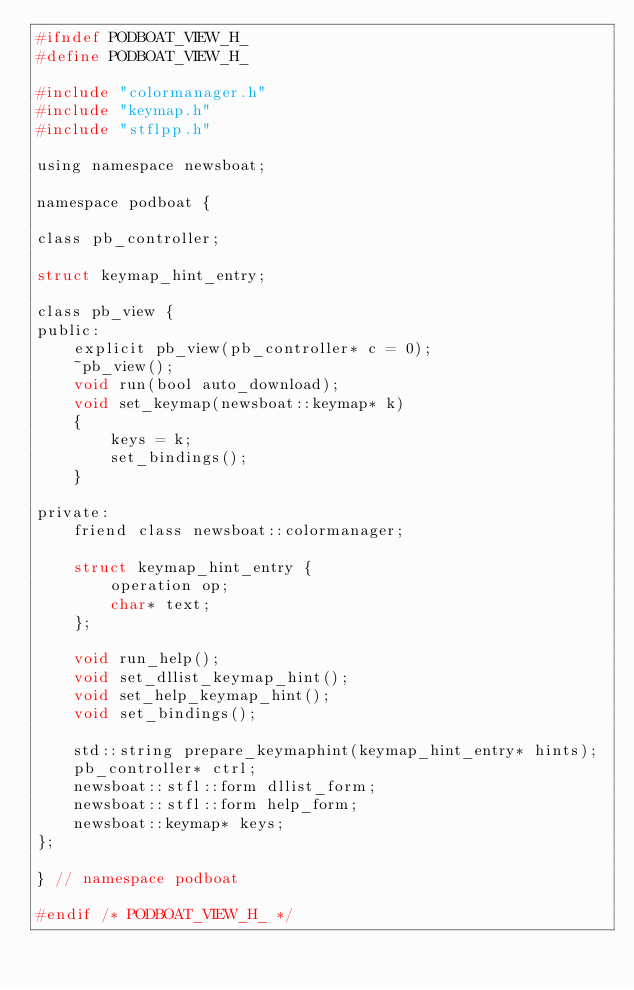Convert code to text. <code><loc_0><loc_0><loc_500><loc_500><_C_>#ifndef PODBOAT_VIEW_H_
#define PODBOAT_VIEW_H_

#include "colormanager.h"
#include "keymap.h"
#include "stflpp.h"

using namespace newsboat;

namespace podboat {

class pb_controller;

struct keymap_hint_entry;

class pb_view {
public:
	explicit pb_view(pb_controller* c = 0);
	~pb_view();
	void run(bool auto_download);
	void set_keymap(newsboat::keymap* k)
	{
		keys = k;
		set_bindings();
	}

private:
	friend class newsboat::colormanager;

	struct keymap_hint_entry {
		operation op;
		char* text;
	};

	void run_help();
	void set_dllist_keymap_hint();
	void set_help_keymap_hint();
	void set_bindings();

	std::string prepare_keymaphint(keymap_hint_entry* hints);
	pb_controller* ctrl;
	newsboat::stfl::form dllist_form;
	newsboat::stfl::form help_form;
	newsboat::keymap* keys;
};

} // namespace podboat

#endif /* PODBOAT_VIEW_H_ */
</code> 